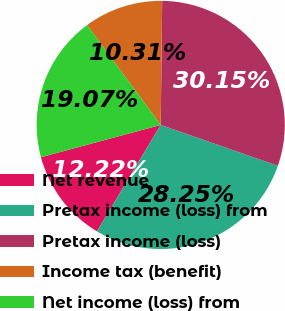Convert chart to OTSL. <chart><loc_0><loc_0><loc_500><loc_500><pie_chart><fcel>Net revenue<fcel>Pretax income (loss) from<fcel>Pretax income (loss)<fcel>Income tax (benefit)<fcel>Net income (loss) from<nl><fcel>12.22%<fcel>28.25%<fcel>30.15%<fcel>10.31%<fcel>19.07%<nl></chart> 